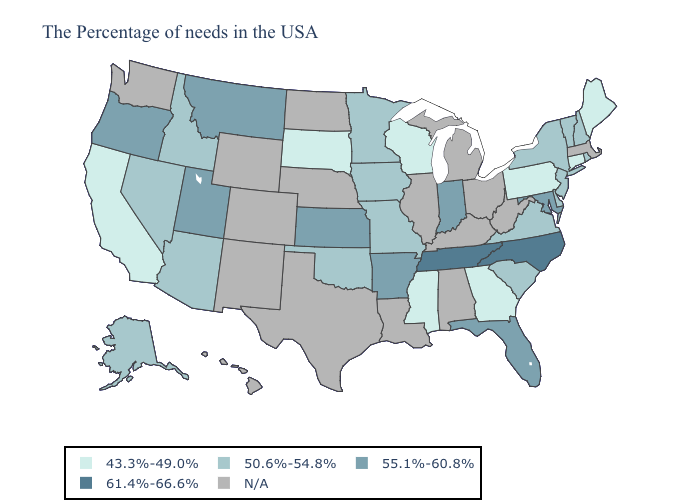Name the states that have a value in the range 55.1%-60.8%?
Give a very brief answer. Maryland, Florida, Indiana, Arkansas, Kansas, Utah, Montana, Oregon. What is the value of Nevada?
Keep it brief. 50.6%-54.8%. Among the states that border Wyoming , does Montana have the lowest value?
Keep it brief. No. Which states have the lowest value in the USA?
Short answer required. Maine, Connecticut, Pennsylvania, Georgia, Wisconsin, Mississippi, South Dakota, California. Does Maine have the highest value in the Northeast?
Quick response, please. No. What is the value of Michigan?
Answer briefly. N/A. Which states have the highest value in the USA?
Be succinct. North Carolina, Tennessee. Name the states that have a value in the range 50.6%-54.8%?
Keep it brief. Rhode Island, New Hampshire, Vermont, New York, New Jersey, Delaware, Virginia, South Carolina, Missouri, Minnesota, Iowa, Oklahoma, Arizona, Idaho, Nevada, Alaska. Which states hav the highest value in the MidWest?
Be succinct. Indiana, Kansas. Among the states that border New York , does Connecticut have the lowest value?
Answer briefly. Yes. What is the highest value in the West ?
Quick response, please. 55.1%-60.8%. Among the states that border Pennsylvania , which have the lowest value?
Be succinct. New York, New Jersey, Delaware. Name the states that have a value in the range 61.4%-66.6%?
Keep it brief. North Carolina, Tennessee. 